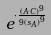Convert formula to latex. <formula><loc_0><loc_0><loc_500><loc_500>e ^ { \cdot \frac { ( A \cdot C ) ^ { 9 } } { 9 { ( s _ { A } ) } ^ { 9 } } }</formula> 